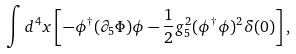Convert formula to latex. <formula><loc_0><loc_0><loc_500><loc_500>\int d ^ { 4 } x \left [ - \phi ^ { \dagger } ( \partial _ { 5 } \Phi ) \phi - \frac { 1 } { 2 } g _ { 5 } ^ { 2 } ( \phi ^ { \dagger } \phi ) ^ { 2 } \delta ( 0 ) \right ] ,</formula> 